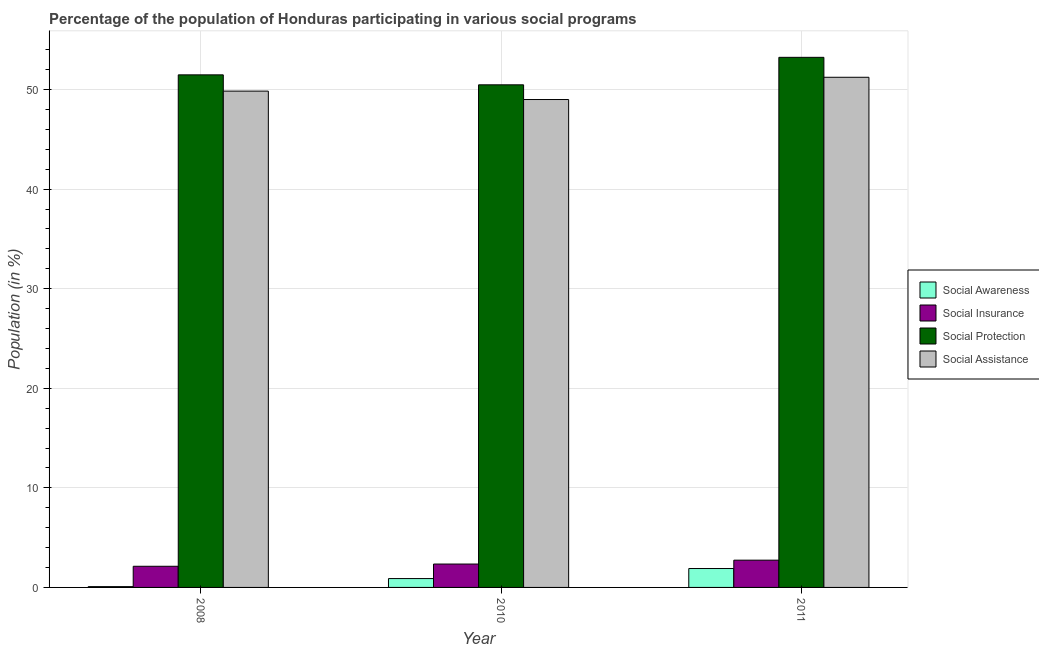Are the number of bars on each tick of the X-axis equal?
Provide a succinct answer. Yes. How many bars are there on the 2nd tick from the right?
Offer a terse response. 4. In how many cases, is the number of bars for a given year not equal to the number of legend labels?
Provide a short and direct response. 0. What is the participation of population in social awareness programs in 2011?
Your answer should be very brief. 1.9. Across all years, what is the maximum participation of population in social awareness programs?
Give a very brief answer. 1.9. Across all years, what is the minimum participation of population in social awareness programs?
Provide a succinct answer. 0.08. What is the total participation of population in social awareness programs in the graph?
Keep it short and to the point. 2.87. What is the difference between the participation of population in social assistance programs in 2010 and that in 2011?
Offer a terse response. -2.23. What is the difference between the participation of population in social assistance programs in 2010 and the participation of population in social awareness programs in 2011?
Your answer should be very brief. -2.23. What is the average participation of population in social awareness programs per year?
Keep it short and to the point. 0.96. In how many years, is the participation of population in social insurance programs greater than 22 %?
Keep it short and to the point. 0. What is the ratio of the participation of population in social assistance programs in 2008 to that in 2011?
Your response must be concise. 0.97. Is the participation of population in social protection programs in 2008 less than that in 2010?
Provide a succinct answer. No. Is the difference between the participation of population in social protection programs in 2008 and 2010 greater than the difference between the participation of population in social awareness programs in 2008 and 2010?
Your response must be concise. No. What is the difference between the highest and the second highest participation of population in social protection programs?
Provide a succinct answer. 1.76. What is the difference between the highest and the lowest participation of population in social protection programs?
Ensure brevity in your answer.  2.76. What does the 1st bar from the left in 2011 represents?
Your answer should be compact. Social Awareness. What does the 1st bar from the right in 2011 represents?
Ensure brevity in your answer.  Social Assistance. Is it the case that in every year, the sum of the participation of population in social awareness programs and participation of population in social insurance programs is greater than the participation of population in social protection programs?
Ensure brevity in your answer.  No. Are all the bars in the graph horizontal?
Your response must be concise. No. Does the graph contain grids?
Provide a short and direct response. Yes. Where does the legend appear in the graph?
Provide a short and direct response. Center right. What is the title of the graph?
Ensure brevity in your answer.  Percentage of the population of Honduras participating in various social programs . What is the label or title of the Y-axis?
Make the answer very short. Population (in %). What is the Population (in %) in Social Awareness in 2008?
Keep it short and to the point. 0.08. What is the Population (in %) of Social Insurance in 2008?
Keep it short and to the point. 2.12. What is the Population (in %) in Social Protection in 2008?
Ensure brevity in your answer.  51.48. What is the Population (in %) of Social Assistance in 2008?
Offer a terse response. 49.85. What is the Population (in %) of Social Awareness in 2010?
Provide a short and direct response. 0.89. What is the Population (in %) of Social Insurance in 2010?
Keep it short and to the point. 2.35. What is the Population (in %) of Social Protection in 2010?
Your answer should be very brief. 50.48. What is the Population (in %) in Social Assistance in 2010?
Make the answer very short. 49. What is the Population (in %) in Social Awareness in 2011?
Your answer should be compact. 1.9. What is the Population (in %) of Social Insurance in 2011?
Your answer should be very brief. 2.74. What is the Population (in %) of Social Protection in 2011?
Give a very brief answer. 53.24. What is the Population (in %) of Social Assistance in 2011?
Keep it short and to the point. 51.24. Across all years, what is the maximum Population (in %) of Social Awareness?
Your answer should be compact. 1.9. Across all years, what is the maximum Population (in %) of Social Insurance?
Ensure brevity in your answer.  2.74. Across all years, what is the maximum Population (in %) in Social Protection?
Keep it short and to the point. 53.24. Across all years, what is the maximum Population (in %) of Social Assistance?
Ensure brevity in your answer.  51.24. Across all years, what is the minimum Population (in %) of Social Awareness?
Ensure brevity in your answer.  0.08. Across all years, what is the minimum Population (in %) in Social Insurance?
Give a very brief answer. 2.12. Across all years, what is the minimum Population (in %) of Social Protection?
Provide a succinct answer. 50.48. Across all years, what is the minimum Population (in %) in Social Assistance?
Keep it short and to the point. 49. What is the total Population (in %) of Social Awareness in the graph?
Ensure brevity in your answer.  2.87. What is the total Population (in %) in Social Insurance in the graph?
Make the answer very short. 7.21. What is the total Population (in %) of Social Protection in the graph?
Provide a succinct answer. 155.21. What is the total Population (in %) in Social Assistance in the graph?
Your response must be concise. 150.09. What is the difference between the Population (in %) of Social Awareness in 2008 and that in 2010?
Provide a succinct answer. -0.81. What is the difference between the Population (in %) in Social Insurance in 2008 and that in 2010?
Offer a terse response. -0.22. What is the difference between the Population (in %) of Social Protection in 2008 and that in 2010?
Provide a succinct answer. 1. What is the difference between the Population (in %) in Social Assistance in 2008 and that in 2010?
Your answer should be very brief. 0.84. What is the difference between the Population (in %) in Social Awareness in 2008 and that in 2011?
Your answer should be very brief. -1.82. What is the difference between the Population (in %) in Social Insurance in 2008 and that in 2011?
Your response must be concise. -0.61. What is the difference between the Population (in %) of Social Protection in 2008 and that in 2011?
Keep it short and to the point. -1.76. What is the difference between the Population (in %) in Social Assistance in 2008 and that in 2011?
Keep it short and to the point. -1.39. What is the difference between the Population (in %) of Social Awareness in 2010 and that in 2011?
Offer a terse response. -1.01. What is the difference between the Population (in %) in Social Insurance in 2010 and that in 2011?
Your response must be concise. -0.39. What is the difference between the Population (in %) in Social Protection in 2010 and that in 2011?
Your answer should be compact. -2.76. What is the difference between the Population (in %) in Social Assistance in 2010 and that in 2011?
Your answer should be very brief. -2.23. What is the difference between the Population (in %) of Social Awareness in 2008 and the Population (in %) of Social Insurance in 2010?
Ensure brevity in your answer.  -2.27. What is the difference between the Population (in %) of Social Awareness in 2008 and the Population (in %) of Social Protection in 2010?
Make the answer very short. -50.4. What is the difference between the Population (in %) in Social Awareness in 2008 and the Population (in %) in Social Assistance in 2010?
Offer a very short reply. -48.92. What is the difference between the Population (in %) in Social Insurance in 2008 and the Population (in %) in Social Protection in 2010?
Offer a terse response. -48.36. What is the difference between the Population (in %) in Social Insurance in 2008 and the Population (in %) in Social Assistance in 2010?
Offer a very short reply. -46.88. What is the difference between the Population (in %) of Social Protection in 2008 and the Population (in %) of Social Assistance in 2010?
Offer a terse response. 2.48. What is the difference between the Population (in %) in Social Awareness in 2008 and the Population (in %) in Social Insurance in 2011?
Ensure brevity in your answer.  -2.66. What is the difference between the Population (in %) in Social Awareness in 2008 and the Population (in %) in Social Protection in 2011?
Keep it short and to the point. -53.16. What is the difference between the Population (in %) in Social Awareness in 2008 and the Population (in %) in Social Assistance in 2011?
Keep it short and to the point. -51.16. What is the difference between the Population (in %) of Social Insurance in 2008 and the Population (in %) of Social Protection in 2011?
Your response must be concise. -51.12. What is the difference between the Population (in %) in Social Insurance in 2008 and the Population (in %) in Social Assistance in 2011?
Provide a short and direct response. -49.11. What is the difference between the Population (in %) of Social Protection in 2008 and the Population (in %) of Social Assistance in 2011?
Provide a succinct answer. 0.24. What is the difference between the Population (in %) of Social Awareness in 2010 and the Population (in %) of Social Insurance in 2011?
Offer a very short reply. -1.85. What is the difference between the Population (in %) of Social Awareness in 2010 and the Population (in %) of Social Protection in 2011?
Your answer should be compact. -52.35. What is the difference between the Population (in %) of Social Awareness in 2010 and the Population (in %) of Social Assistance in 2011?
Your answer should be very brief. -50.35. What is the difference between the Population (in %) of Social Insurance in 2010 and the Population (in %) of Social Protection in 2011?
Your answer should be compact. -50.89. What is the difference between the Population (in %) of Social Insurance in 2010 and the Population (in %) of Social Assistance in 2011?
Give a very brief answer. -48.89. What is the difference between the Population (in %) in Social Protection in 2010 and the Population (in %) in Social Assistance in 2011?
Give a very brief answer. -0.76. What is the average Population (in %) of Social Awareness per year?
Your answer should be very brief. 0.96. What is the average Population (in %) of Social Insurance per year?
Offer a terse response. 2.4. What is the average Population (in %) in Social Protection per year?
Ensure brevity in your answer.  51.74. What is the average Population (in %) of Social Assistance per year?
Offer a terse response. 50.03. In the year 2008, what is the difference between the Population (in %) in Social Awareness and Population (in %) in Social Insurance?
Your answer should be very brief. -2.04. In the year 2008, what is the difference between the Population (in %) in Social Awareness and Population (in %) in Social Protection?
Keep it short and to the point. -51.4. In the year 2008, what is the difference between the Population (in %) in Social Awareness and Population (in %) in Social Assistance?
Provide a succinct answer. -49.77. In the year 2008, what is the difference between the Population (in %) in Social Insurance and Population (in %) in Social Protection?
Offer a terse response. -49.36. In the year 2008, what is the difference between the Population (in %) of Social Insurance and Population (in %) of Social Assistance?
Offer a terse response. -47.72. In the year 2008, what is the difference between the Population (in %) in Social Protection and Population (in %) in Social Assistance?
Offer a terse response. 1.63. In the year 2010, what is the difference between the Population (in %) in Social Awareness and Population (in %) in Social Insurance?
Your answer should be compact. -1.46. In the year 2010, what is the difference between the Population (in %) of Social Awareness and Population (in %) of Social Protection?
Keep it short and to the point. -49.59. In the year 2010, what is the difference between the Population (in %) in Social Awareness and Population (in %) in Social Assistance?
Give a very brief answer. -48.12. In the year 2010, what is the difference between the Population (in %) of Social Insurance and Population (in %) of Social Protection?
Your response must be concise. -48.13. In the year 2010, what is the difference between the Population (in %) of Social Insurance and Population (in %) of Social Assistance?
Your response must be concise. -46.66. In the year 2010, what is the difference between the Population (in %) in Social Protection and Population (in %) in Social Assistance?
Keep it short and to the point. 1.48. In the year 2011, what is the difference between the Population (in %) of Social Awareness and Population (in %) of Social Insurance?
Make the answer very short. -0.84. In the year 2011, what is the difference between the Population (in %) in Social Awareness and Population (in %) in Social Protection?
Your response must be concise. -51.34. In the year 2011, what is the difference between the Population (in %) of Social Awareness and Population (in %) of Social Assistance?
Your answer should be very brief. -49.34. In the year 2011, what is the difference between the Population (in %) in Social Insurance and Population (in %) in Social Protection?
Offer a terse response. -50.5. In the year 2011, what is the difference between the Population (in %) in Social Insurance and Population (in %) in Social Assistance?
Give a very brief answer. -48.5. In the year 2011, what is the difference between the Population (in %) of Social Protection and Population (in %) of Social Assistance?
Ensure brevity in your answer.  2. What is the ratio of the Population (in %) in Social Awareness in 2008 to that in 2010?
Your response must be concise. 0.09. What is the ratio of the Population (in %) in Social Insurance in 2008 to that in 2010?
Give a very brief answer. 0.9. What is the ratio of the Population (in %) of Social Protection in 2008 to that in 2010?
Keep it short and to the point. 1.02. What is the ratio of the Population (in %) of Social Assistance in 2008 to that in 2010?
Keep it short and to the point. 1.02. What is the ratio of the Population (in %) in Social Awareness in 2008 to that in 2011?
Make the answer very short. 0.04. What is the ratio of the Population (in %) in Social Insurance in 2008 to that in 2011?
Make the answer very short. 0.78. What is the ratio of the Population (in %) of Social Protection in 2008 to that in 2011?
Your answer should be very brief. 0.97. What is the ratio of the Population (in %) of Social Assistance in 2008 to that in 2011?
Provide a short and direct response. 0.97. What is the ratio of the Population (in %) of Social Awareness in 2010 to that in 2011?
Provide a short and direct response. 0.47. What is the ratio of the Population (in %) in Social Insurance in 2010 to that in 2011?
Provide a short and direct response. 0.86. What is the ratio of the Population (in %) in Social Protection in 2010 to that in 2011?
Keep it short and to the point. 0.95. What is the ratio of the Population (in %) of Social Assistance in 2010 to that in 2011?
Offer a terse response. 0.96. What is the difference between the highest and the second highest Population (in %) of Social Awareness?
Provide a short and direct response. 1.01. What is the difference between the highest and the second highest Population (in %) of Social Insurance?
Ensure brevity in your answer.  0.39. What is the difference between the highest and the second highest Population (in %) of Social Protection?
Offer a terse response. 1.76. What is the difference between the highest and the second highest Population (in %) of Social Assistance?
Offer a very short reply. 1.39. What is the difference between the highest and the lowest Population (in %) of Social Awareness?
Your answer should be very brief. 1.82. What is the difference between the highest and the lowest Population (in %) of Social Insurance?
Provide a short and direct response. 0.61. What is the difference between the highest and the lowest Population (in %) of Social Protection?
Provide a succinct answer. 2.76. What is the difference between the highest and the lowest Population (in %) of Social Assistance?
Offer a terse response. 2.23. 